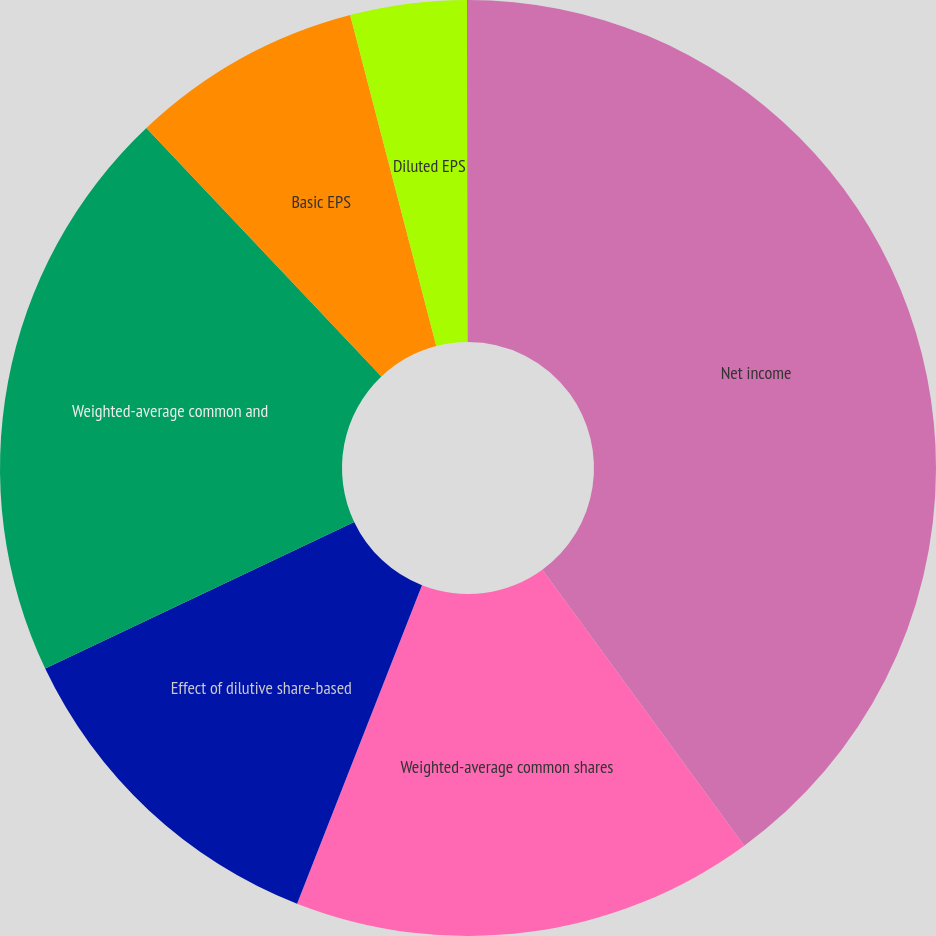Convert chart to OTSL. <chart><loc_0><loc_0><loc_500><loc_500><pie_chart><fcel>Net income<fcel>Weighted-average common shares<fcel>Effect of dilutive share-based<fcel>Weighted-average common and<fcel>Basic EPS<fcel>Diluted EPS<fcel>Unexercised employee stock<nl><fcel>39.95%<fcel>16.0%<fcel>12.0%<fcel>19.99%<fcel>8.01%<fcel>4.02%<fcel>0.03%<nl></chart> 